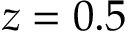Convert formula to latex. <formula><loc_0><loc_0><loc_500><loc_500>z = 0 . 5</formula> 